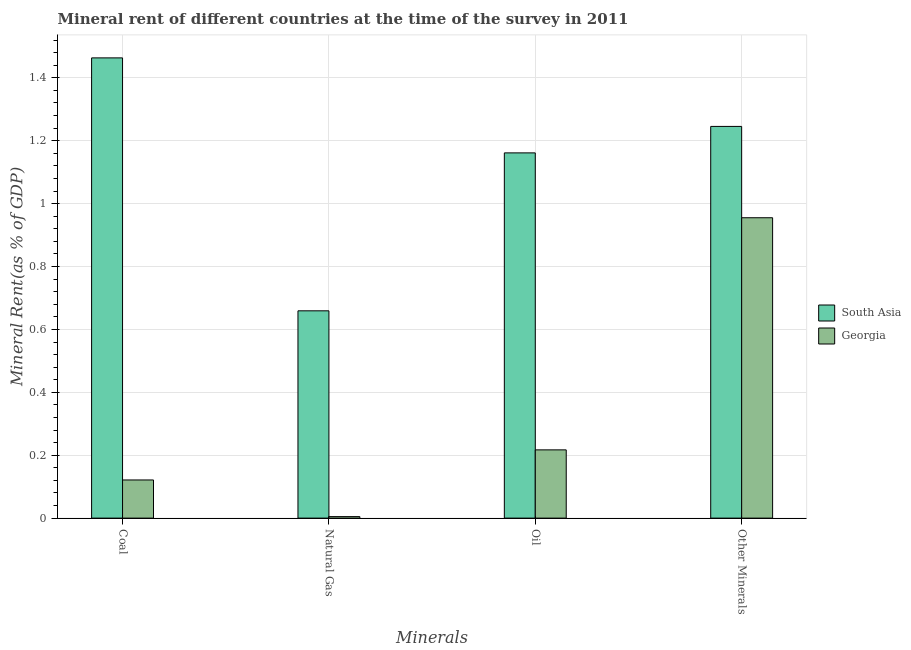Are the number of bars per tick equal to the number of legend labels?
Give a very brief answer. Yes. Are the number of bars on each tick of the X-axis equal?
Your response must be concise. Yes. How many bars are there on the 2nd tick from the left?
Offer a very short reply. 2. How many bars are there on the 1st tick from the right?
Make the answer very short. 2. What is the label of the 4th group of bars from the left?
Provide a short and direct response. Other Minerals. What is the natural gas rent in South Asia?
Your answer should be very brief. 0.66. Across all countries, what is the maximum  rent of other minerals?
Offer a terse response. 1.25. Across all countries, what is the minimum natural gas rent?
Ensure brevity in your answer.  0. In which country was the oil rent minimum?
Your answer should be very brief. Georgia. What is the total coal rent in the graph?
Offer a very short reply. 1.58. What is the difference between the  rent of other minerals in Georgia and that in South Asia?
Offer a terse response. -0.29. What is the difference between the coal rent in South Asia and the natural gas rent in Georgia?
Make the answer very short. 1.46. What is the average oil rent per country?
Your answer should be compact. 0.69. What is the difference between the coal rent and oil rent in Georgia?
Provide a succinct answer. -0.1. What is the ratio of the oil rent in South Asia to that in Georgia?
Provide a short and direct response. 5.35. Is the natural gas rent in Georgia less than that in South Asia?
Provide a short and direct response. Yes. What is the difference between the highest and the second highest coal rent?
Offer a terse response. 1.34. What is the difference between the highest and the lowest  rent of other minerals?
Provide a succinct answer. 0.29. Is it the case that in every country, the sum of the  rent of other minerals and natural gas rent is greater than the sum of oil rent and coal rent?
Your answer should be compact. Yes. What does the 2nd bar from the left in Natural Gas represents?
Your answer should be compact. Georgia. What does the 1st bar from the right in Natural Gas represents?
Provide a short and direct response. Georgia. Are all the bars in the graph horizontal?
Your answer should be compact. No. How many countries are there in the graph?
Give a very brief answer. 2. What is the difference between two consecutive major ticks on the Y-axis?
Make the answer very short. 0.2. How many legend labels are there?
Your response must be concise. 2. What is the title of the graph?
Give a very brief answer. Mineral rent of different countries at the time of the survey in 2011. What is the label or title of the X-axis?
Provide a succinct answer. Minerals. What is the label or title of the Y-axis?
Offer a very short reply. Mineral Rent(as % of GDP). What is the Mineral Rent(as % of GDP) in South Asia in Coal?
Give a very brief answer. 1.46. What is the Mineral Rent(as % of GDP) in Georgia in Coal?
Your answer should be compact. 0.12. What is the Mineral Rent(as % of GDP) in South Asia in Natural Gas?
Provide a short and direct response. 0.66. What is the Mineral Rent(as % of GDP) in Georgia in Natural Gas?
Your response must be concise. 0. What is the Mineral Rent(as % of GDP) in South Asia in Oil?
Offer a very short reply. 1.16. What is the Mineral Rent(as % of GDP) in Georgia in Oil?
Ensure brevity in your answer.  0.22. What is the Mineral Rent(as % of GDP) of South Asia in Other Minerals?
Provide a succinct answer. 1.25. What is the Mineral Rent(as % of GDP) in Georgia in Other Minerals?
Your answer should be compact. 0.96. Across all Minerals, what is the maximum Mineral Rent(as % of GDP) of South Asia?
Your response must be concise. 1.46. Across all Minerals, what is the maximum Mineral Rent(as % of GDP) in Georgia?
Give a very brief answer. 0.96. Across all Minerals, what is the minimum Mineral Rent(as % of GDP) in South Asia?
Make the answer very short. 0.66. Across all Minerals, what is the minimum Mineral Rent(as % of GDP) of Georgia?
Ensure brevity in your answer.  0. What is the total Mineral Rent(as % of GDP) in South Asia in the graph?
Give a very brief answer. 4.53. What is the total Mineral Rent(as % of GDP) of Georgia in the graph?
Make the answer very short. 1.3. What is the difference between the Mineral Rent(as % of GDP) of South Asia in Coal and that in Natural Gas?
Give a very brief answer. 0.8. What is the difference between the Mineral Rent(as % of GDP) of Georgia in Coal and that in Natural Gas?
Provide a short and direct response. 0.12. What is the difference between the Mineral Rent(as % of GDP) in South Asia in Coal and that in Oil?
Your response must be concise. 0.3. What is the difference between the Mineral Rent(as % of GDP) in Georgia in Coal and that in Oil?
Your response must be concise. -0.1. What is the difference between the Mineral Rent(as % of GDP) of South Asia in Coal and that in Other Minerals?
Your response must be concise. 0.22. What is the difference between the Mineral Rent(as % of GDP) of Georgia in Coal and that in Other Minerals?
Your response must be concise. -0.83. What is the difference between the Mineral Rent(as % of GDP) in South Asia in Natural Gas and that in Oil?
Provide a short and direct response. -0.5. What is the difference between the Mineral Rent(as % of GDP) in Georgia in Natural Gas and that in Oil?
Your answer should be compact. -0.21. What is the difference between the Mineral Rent(as % of GDP) in South Asia in Natural Gas and that in Other Minerals?
Give a very brief answer. -0.59. What is the difference between the Mineral Rent(as % of GDP) in Georgia in Natural Gas and that in Other Minerals?
Provide a short and direct response. -0.95. What is the difference between the Mineral Rent(as % of GDP) in South Asia in Oil and that in Other Minerals?
Your answer should be very brief. -0.08. What is the difference between the Mineral Rent(as % of GDP) of Georgia in Oil and that in Other Minerals?
Keep it short and to the point. -0.74. What is the difference between the Mineral Rent(as % of GDP) of South Asia in Coal and the Mineral Rent(as % of GDP) of Georgia in Natural Gas?
Your answer should be very brief. 1.46. What is the difference between the Mineral Rent(as % of GDP) of South Asia in Coal and the Mineral Rent(as % of GDP) of Georgia in Oil?
Offer a terse response. 1.25. What is the difference between the Mineral Rent(as % of GDP) in South Asia in Coal and the Mineral Rent(as % of GDP) in Georgia in Other Minerals?
Give a very brief answer. 0.51. What is the difference between the Mineral Rent(as % of GDP) of South Asia in Natural Gas and the Mineral Rent(as % of GDP) of Georgia in Oil?
Make the answer very short. 0.44. What is the difference between the Mineral Rent(as % of GDP) in South Asia in Natural Gas and the Mineral Rent(as % of GDP) in Georgia in Other Minerals?
Make the answer very short. -0.3. What is the difference between the Mineral Rent(as % of GDP) in South Asia in Oil and the Mineral Rent(as % of GDP) in Georgia in Other Minerals?
Offer a terse response. 0.21. What is the average Mineral Rent(as % of GDP) in South Asia per Minerals?
Keep it short and to the point. 1.13. What is the average Mineral Rent(as % of GDP) of Georgia per Minerals?
Give a very brief answer. 0.32. What is the difference between the Mineral Rent(as % of GDP) in South Asia and Mineral Rent(as % of GDP) in Georgia in Coal?
Keep it short and to the point. 1.34. What is the difference between the Mineral Rent(as % of GDP) of South Asia and Mineral Rent(as % of GDP) of Georgia in Natural Gas?
Offer a terse response. 0.65. What is the difference between the Mineral Rent(as % of GDP) of South Asia and Mineral Rent(as % of GDP) of Georgia in Oil?
Keep it short and to the point. 0.94. What is the difference between the Mineral Rent(as % of GDP) in South Asia and Mineral Rent(as % of GDP) in Georgia in Other Minerals?
Provide a short and direct response. 0.29. What is the ratio of the Mineral Rent(as % of GDP) in South Asia in Coal to that in Natural Gas?
Make the answer very short. 2.22. What is the ratio of the Mineral Rent(as % of GDP) in Georgia in Coal to that in Natural Gas?
Provide a short and direct response. 25.49. What is the ratio of the Mineral Rent(as % of GDP) in South Asia in Coal to that in Oil?
Ensure brevity in your answer.  1.26. What is the ratio of the Mineral Rent(as % of GDP) in Georgia in Coal to that in Oil?
Your response must be concise. 0.56. What is the ratio of the Mineral Rent(as % of GDP) of South Asia in Coal to that in Other Minerals?
Ensure brevity in your answer.  1.17. What is the ratio of the Mineral Rent(as % of GDP) in Georgia in Coal to that in Other Minerals?
Offer a terse response. 0.13. What is the ratio of the Mineral Rent(as % of GDP) of South Asia in Natural Gas to that in Oil?
Offer a terse response. 0.57. What is the ratio of the Mineral Rent(as % of GDP) of Georgia in Natural Gas to that in Oil?
Provide a short and direct response. 0.02. What is the ratio of the Mineral Rent(as % of GDP) of South Asia in Natural Gas to that in Other Minerals?
Your answer should be compact. 0.53. What is the ratio of the Mineral Rent(as % of GDP) of Georgia in Natural Gas to that in Other Minerals?
Give a very brief answer. 0.01. What is the ratio of the Mineral Rent(as % of GDP) in South Asia in Oil to that in Other Minerals?
Your response must be concise. 0.93. What is the ratio of the Mineral Rent(as % of GDP) of Georgia in Oil to that in Other Minerals?
Your response must be concise. 0.23. What is the difference between the highest and the second highest Mineral Rent(as % of GDP) of South Asia?
Make the answer very short. 0.22. What is the difference between the highest and the second highest Mineral Rent(as % of GDP) of Georgia?
Provide a succinct answer. 0.74. What is the difference between the highest and the lowest Mineral Rent(as % of GDP) in South Asia?
Provide a succinct answer. 0.8. What is the difference between the highest and the lowest Mineral Rent(as % of GDP) in Georgia?
Provide a short and direct response. 0.95. 